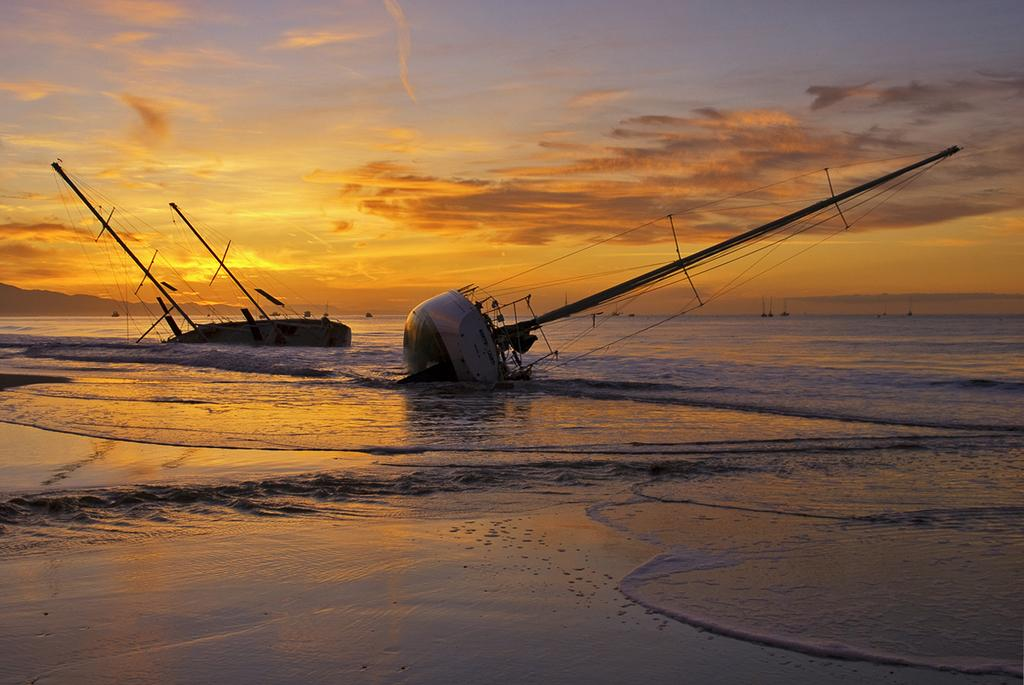What is the main subject of the image? The main subject of the image is boats. Where are the boats located? The boats are on the ocean. Can you describe the condition of the boats? Two of the boats are tilted. What is visible in the background of the image? The sky is visible in the image. How would you describe the weather based on the sky? The sky appears to be cloudy. What discovery was made by the boats in the image? There is no indication in the image that the boats made any discoveries. How does the digestion of the ocean affect the boats in the image? The ocean does not have a digestive system, so it cannot affect the boats in that way. 